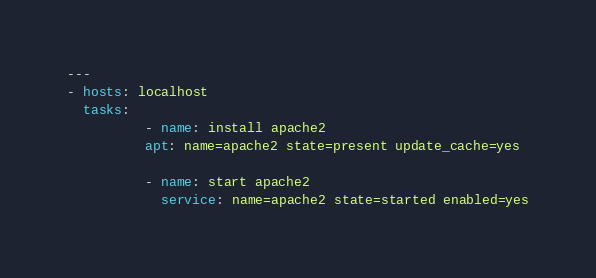Convert code to text. <code><loc_0><loc_0><loc_500><loc_500><_YAML_>---
- hosts: localhost
  tasks:
          - name: install apache2
          apt: name=apache2 state=present update_cache=yes

          - name: start apache2
            service: name=apache2 state=started enabled=yes
</code> 